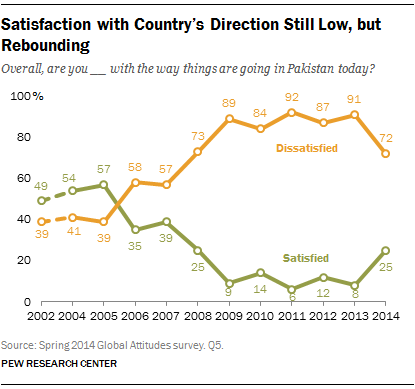Specify some key components in this picture. The highest value of the green color bar is 57. The total value of the highest and lowest points on the orange line is 131. 